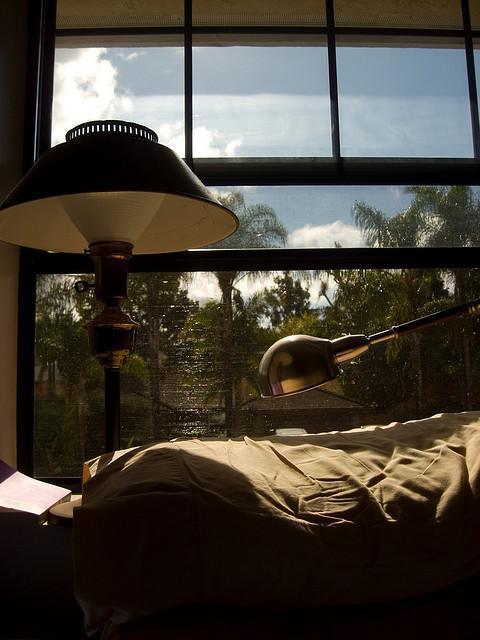How many lamps are visible in the photo?
Give a very brief answer. 2. How many toy mice have a sign?
Give a very brief answer. 0. 